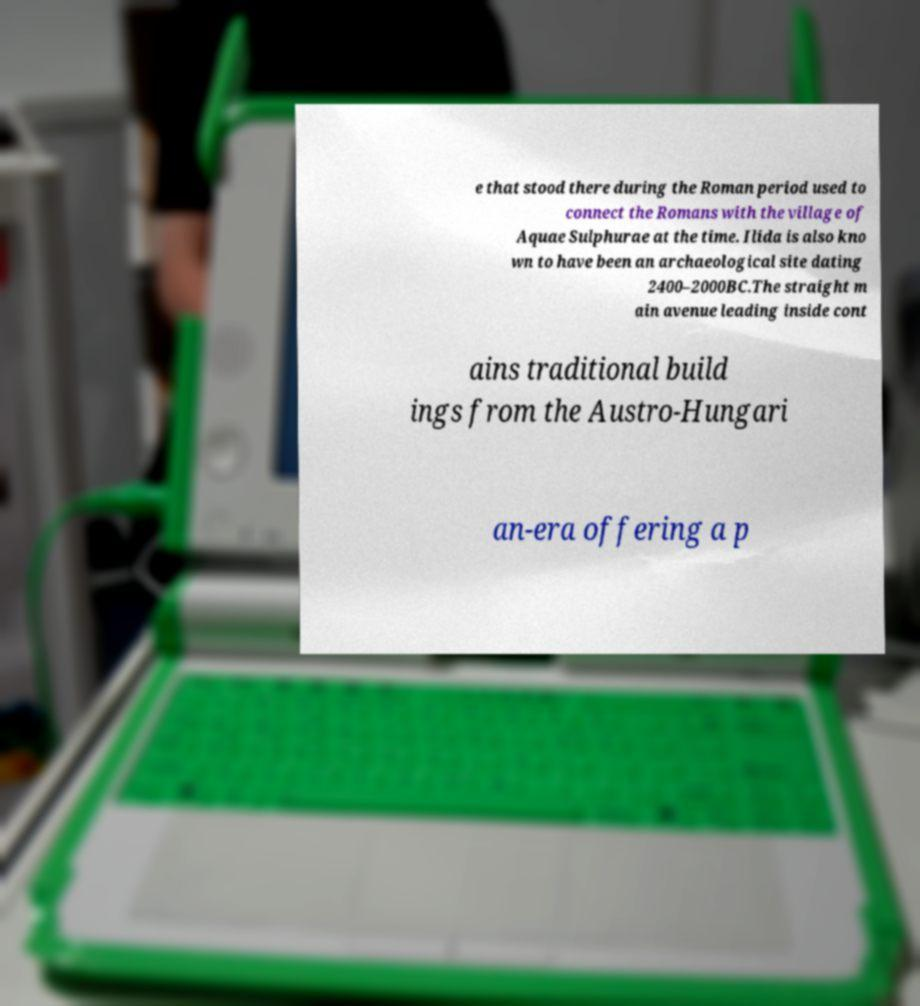Could you assist in decoding the text presented in this image and type it out clearly? e that stood there during the Roman period used to connect the Romans with the village of Aquae Sulphurae at the time. Ilida is also kno wn to have been an archaeological site dating 2400–2000BC.The straight m ain avenue leading inside cont ains traditional build ings from the Austro-Hungari an-era offering a p 